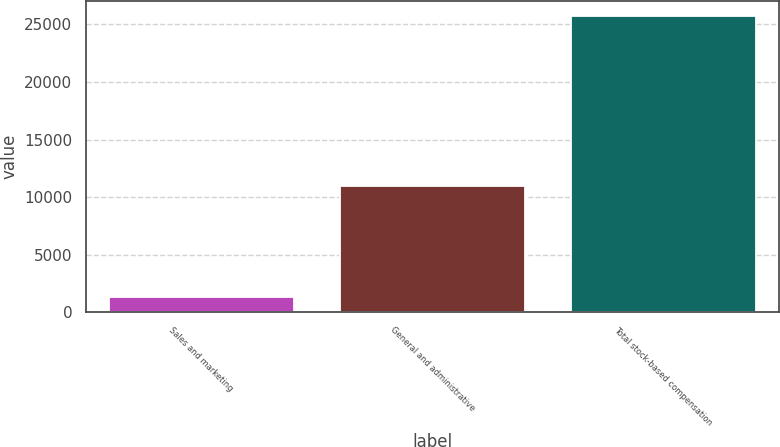Convert chart. <chart><loc_0><loc_0><loc_500><loc_500><bar_chart><fcel>Sales and marketing<fcel>General and administrative<fcel>Total stock-based compensation<nl><fcel>1346<fcel>10973<fcel>25741<nl></chart> 